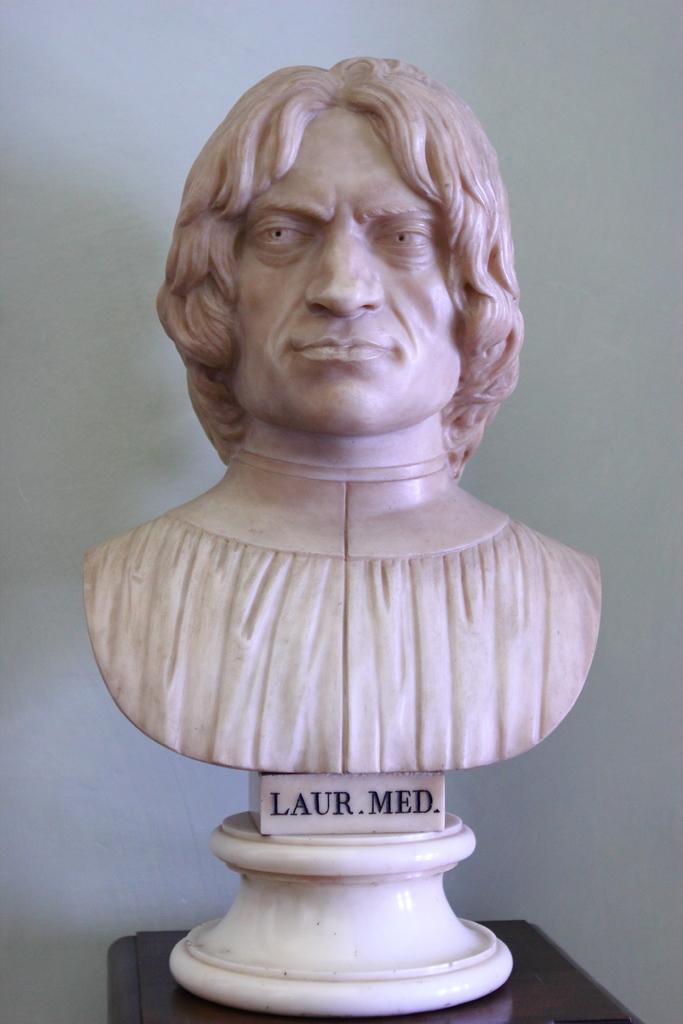How would you summarize this image in a sentence or two? In this image I can see the statue of the person and I can see the name written on it. It is on the table. In the back I can see the white wall. 